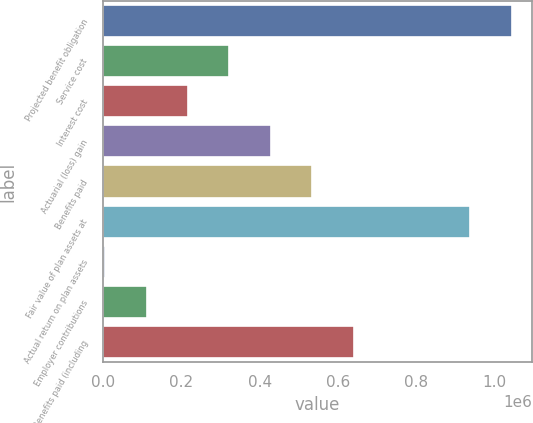<chart> <loc_0><loc_0><loc_500><loc_500><bar_chart><fcel>Projected benefit obligation<fcel>Service cost<fcel>Interest cost<fcel>Actuarial (loss) gain<fcel>Benefits paid<fcel>Fair value of plan assets at<fcel>Actual return on plan assets<fcel>Employer contributions<fcel>Benefits paid (including<nl><fcel>1.0444e+06<fcel>323033<fcel>217175<fcel>428892<fcel>534750<fcel>938544<fcel>5458<fcel>111316<fcel>640608<nl></chart> 